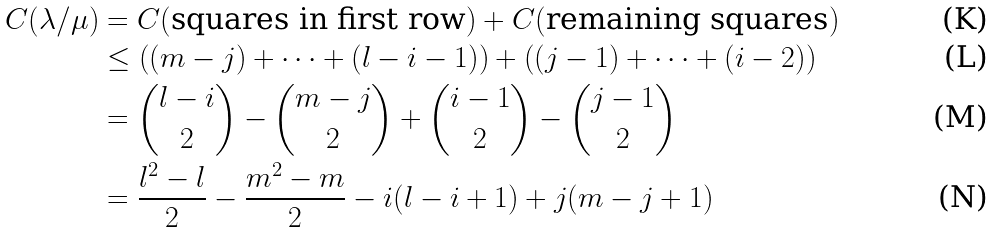Convert formula to latex. <formula><loc_0><loc_0><loc_500><loc_500>C ( \lambda / \mu ) & = C ( \text {squares in first row} ) + C ( \text {remaining squares} ) \\ & \leq \left ( ( m - j ) + \dots + ( l - i - 1 ) \right ) + \left ( ( j - 1 ) + \dots + ( i - 2 ) \right ) \\ & = { l - i \choose 2 } - { m - j \choose 2 } + { i - 1 \choose 2 } - { j - 1 \choose 2 } \\ & = \frac { l ^ { 2 } - l } { 2 } - \frac { m ^ { 2 } - m } { 2 } - i ( l - i + 1 ) + j ( m - j + 1 )</formula> 